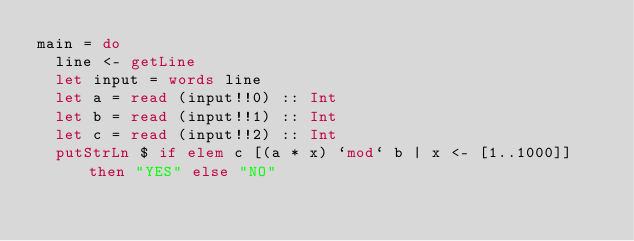<code> <loc_0><loc_0><loc_500><loc_500><_Haskell_>main = do
  line <- getLine
  let input = words line
  let a = read (input!!0) :: Int
  let b = read (input!!1) :: Int
  let c = read (input!!2) :: Int
  putStrLn $ if elem c [(a * x) `mod` b | x <- [1..1000]] then "YES" else "NO"</code> 